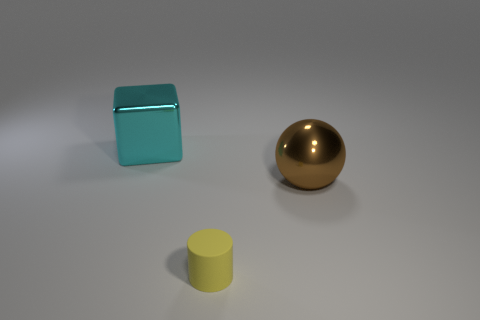How many big cyan objects have the same material as the brown sphere?
Give a very brief answer. 1. Does the thing that is behind the brown sphere have the same size as the shiny thing to the right of the small cylinder?
Keep it short and to the point. Yes. There is a large object that is in front of the shiny object that is to the left of the brown ball; what is it made of?
Your answer should be very brief. Metal. Are there fewer shiny cubes that are in front of the tiny yellow rubber object than small objects on the left side of the big cyan metal object?
Offer a terse response. No. Is there anything else that has the same shape as the cyan metallic thing?
Your response must be concise. No. There is a big thing to the right of the cylinder; what material is it?
Provide a succinct answer. Metal. Is there anything else that has the same size as the brown thing?
Offer a terse response. Yes. There is a small object; are there any cubes on the right side of it?
Your answer should be very brief. No. There is a small yellow thing; what shape is it?
Your answer should be compact. Cylinder. What number of objects are objects to the left of the big brown metal ball or cyan blocks?
Your response must be concise. 2. 